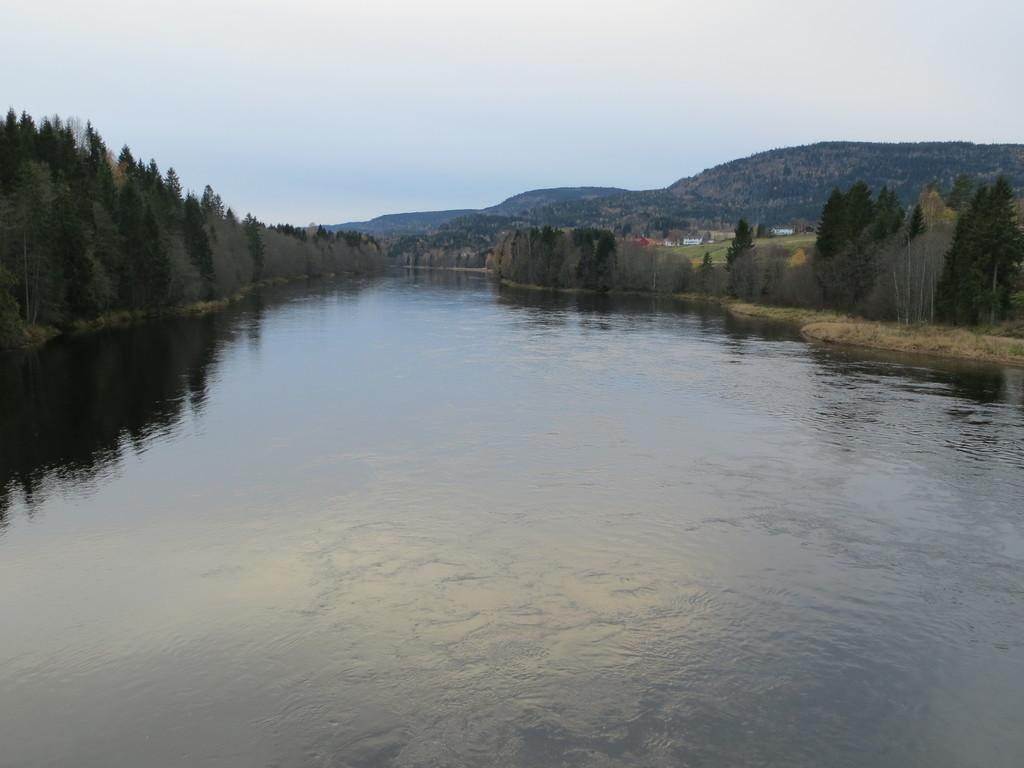What is the primary element visible in the image? There is water in the image. What can be seen on the left side of the image? There are trees on the left side of the image. What can be seen on the right side of the image? There are trees on the right side of the image. What is visible in the background of the image? The sky is visible in the background of the image. What type of star can be seen in the image? There is no star visible in the image; it features water, trees, and the sky. What type of instrument is being played in the image? There is no instrument visible in the image; it features water, trees, and the sky. 